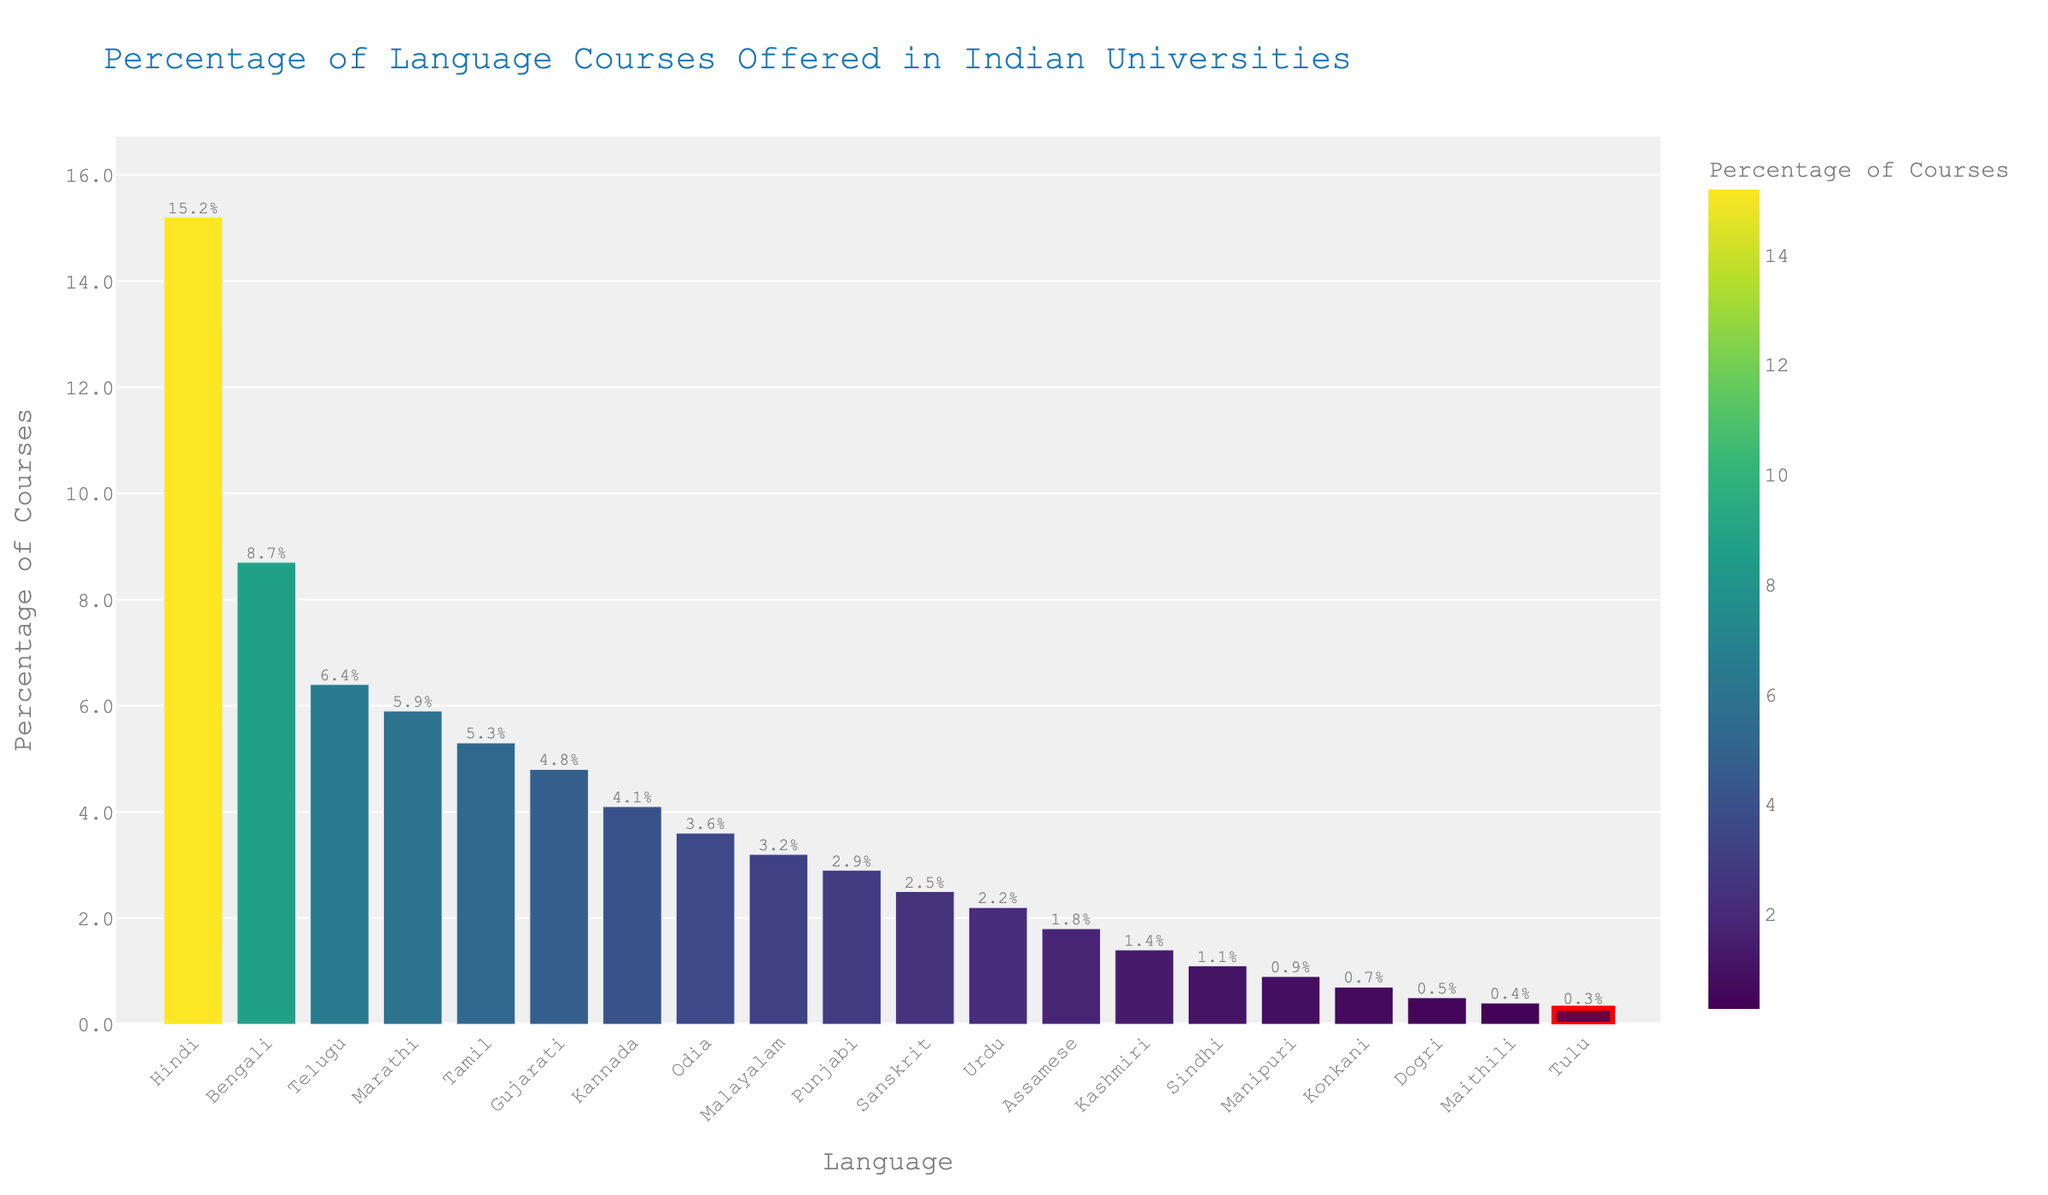Which language has the highest percentage of courses offered? The bar representing Hindi is the tallest and positioned at the left-most side, indicating it has the highest percentage.
Answer: Hindi What percentage of courses are offered for Tulu? The red highlighted bar represents Tulu, and the value label above it shows the percentage.
Answer: 0.3% How much greater is the percentage of Hindi courses compared to Tulu courses? The percentage of Hindi courses is 15.2% and that of Tulu courses is 0.3%, the difference is calculated by subtracting the percentage of Tulu from Hindi (15.2 - 0.3).
Answer: 14.9% Which regional language has just slightly more courses offered than Kannada? The bar for Odia is placed directly next to and slightly higher than the bar for Kannada, showing it has a slightly higher percentage.
Answer: Odia What percentage of courses are offered for regional languages that have percentages below Sanskrit? Identify the languages with percentages less than 2.5% (Sanskrit), then sum their percentages: Urdu (2.2%) + Assamese (1.8%) + Kashmiri (1.4%) + Sindhi (1.1%) + Manipuri (0.9%) + Konkani (0.7%) + Dogri (0.5%) + Maithili (0.4%) + Tulu (0.3%).
Answer: 9.3% Compare the percentages of Tamil and Gujarati courses and state which is higher. The bar for Tamil is slightly lower than the bar for Gujarati, indicating Tamil has a lower percentage.
Answer: Gujarati What is the total percentage of courses offered for Telugu, Marathi, and Tamil combined? Sum the percentages of these languages: Telugu (6.4%) + Marathi (5.9%) + Tamil (5.3%).
Answer: 17.6% Which language is offered just above Tulu in terms of the percentage of courses? The bar immediately above Tulu is for Maithili with a percentage of 0.4%, indicating it is just above Tulu.
Answer: Maithili How many languages have a higher percentage of courses offered than Malayalam? Locate the bar for Malayalam (3.2%) and count all bars that are taller and to its left: Hindi, Bengali, Telugu, Marathi, Tamil, Gujarati, and Kannada.
Answer: 7 